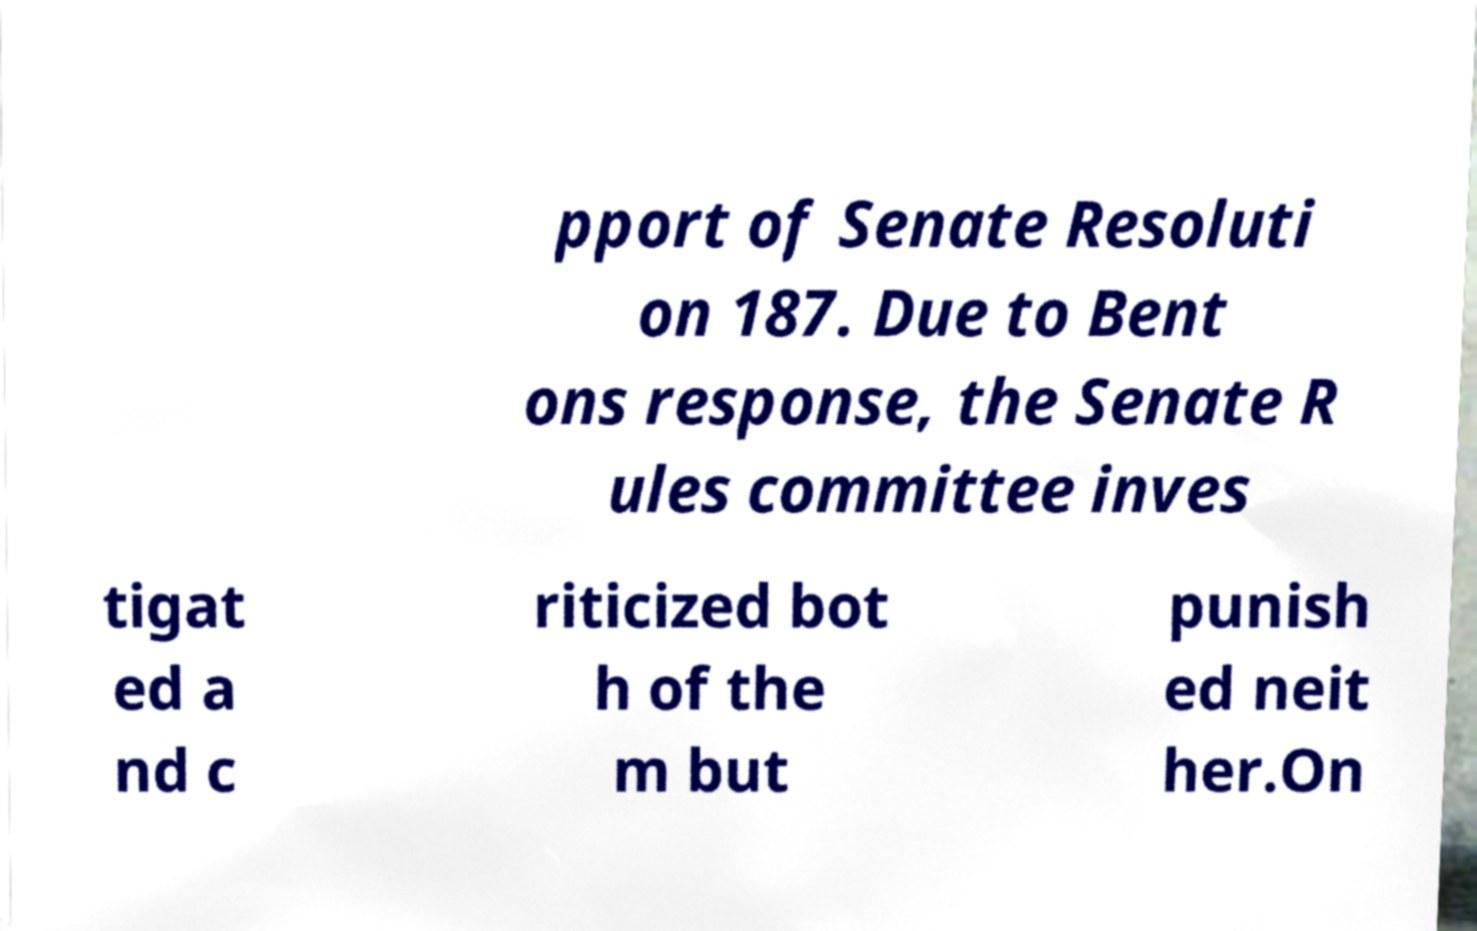There's text embedded in this image that I need extracted. Can you transcribe it verbatim? pport of Senate Resoluti on 187. Due to Bent ons response, the Senate R ules committee inves tigat ed a nd c riticized bot h of the m but punish ed neit her.On 